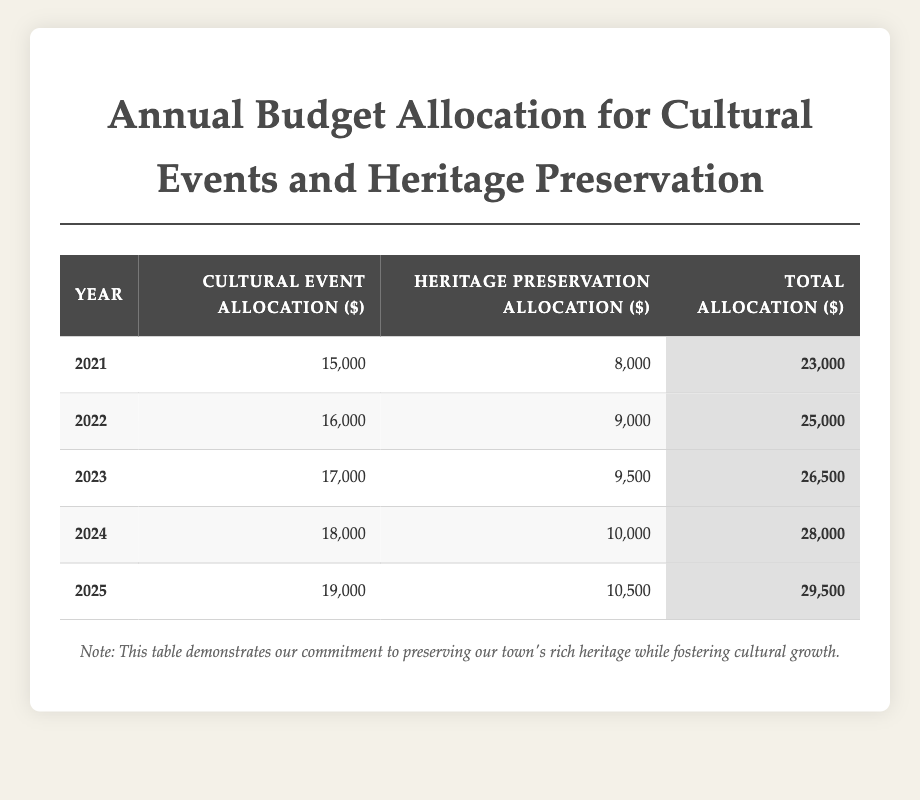What was the total budget allocation for the year 2023? Referring to the table, the total allocation for the year 2023 is listed as 26,500 dollars.
Answer: 26,500 dollars How much was allocated for heritage preservation in 2024? The table indicates that the heritage preservation allocation for the year 2024 is 10,000 dollars.
Answer: 10,000 dollars What is the increase in cultural event allocation from 2021 to 2025? To find the increase, subtract the cultural event allocation for 2021 (15,000 dollars) from that of 2025 (19,000 dollars), which gives 19,000 - 15,000 = 4,000 dollars.
Answer: 4,000 dollars Which year saw the highest total allocation? Looking at the total allocations for each year, the year 2025 has the highest total of 29,500 dollars.
Answer: 2025 Is the heritage preservation allocation for 2022 greater than that for 2023? The table shows that the allocation for heritage preservation in 2022 is 9,000 dollars, and in 2023 it is 9,500 dollars, making it false that 2022's allocation is greater.
Answer: No What is the average cultural event allocation from 2021 to 2025? To calculate the average, sum the cultural event allocations: (15,000 + 16,000 + 17,000 + 18,000 + 19,000) = 85,000 dollars. Then divide by the number of years, 5. So, 85,000 / 5 = 17,000 dollars.
Answer: 17,000 dollars What is the percentage increase in total allocation from 2021 to 2024? First, find the total allocation for 2021 (23,000 dollars) and for 2024 (28,000 dollars). Then, calculate the difference: 28,000 - 23,000 = 5,000 dollars. The percentage increase is (5,000 / 23,000) * 100 ≈ 21.74%.
Answer: Approximately 21.74% In which year did the cultural event allocation first exceed 18,000 dollars? By examining the table, the cultural event allocation first exceeds 18,000 dollars in the year 2024, when it is 18,000 dollars.
Answer: 2024 What is the total heritage preservation allocation from 2021 to 2025? To find the total, sum the heritage preservation allocations: (8,000 + 9,000 + 9,500 + 10,000 + 10,500) = 47,000 dollars.
Answer: 47,000 dollars Was the total allocation in 2022 less than the total allocation in 2023? By comparing the totals, the allocation in 2022 is 25,000 dollars and in 2023 is 26,500 dollars. Thus, it is true that 2022's total is less than 2023's.
Answer: Yes 